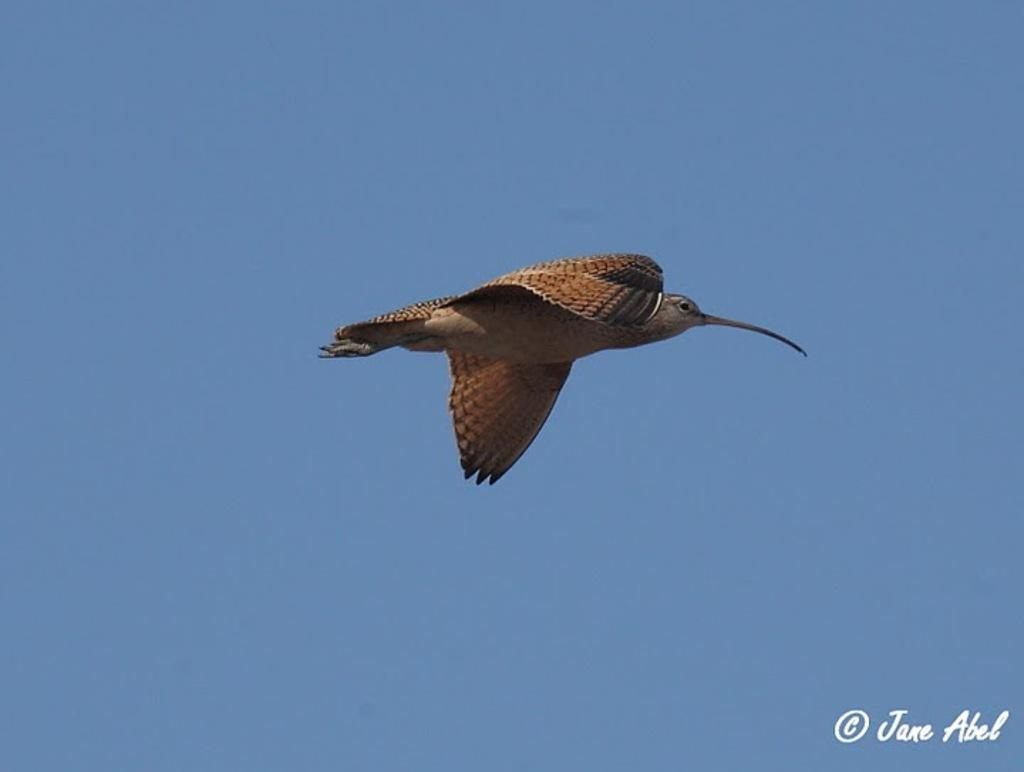What is the main subject of the image? The main subject of the image is a bird flying. What can be seen in the background of the image? The sky is visible in the background of the image. Is there any text present in the image? Yes, the name "Jane Abel" is present in the bottom right corner of the image. What type of harmony is being played by the bird in the image? There is no indication of any harmony being played in the image, as it features a bird flying and the sky in the background. --- 